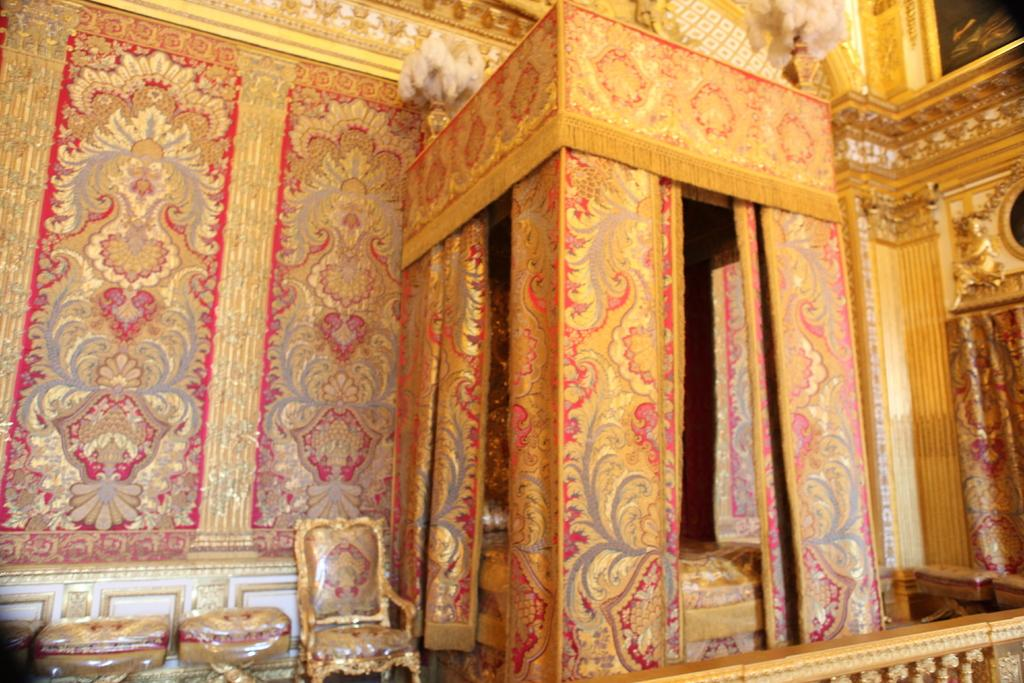What type of location is depicted in the image? The image shows an inside view of a building. What type of furniture is present in the image? There is a bed and chairs visible in the image. What type of window treatment is present in the image? There are curtains in the image. What type of structure is visible in the image? There are walls visible in the image. What other objects can be seen in the image? There are other objects present in the image. What type of sound can be heard coming from the girl in the image? There is no girl present in the image, so it is not possible to determine what sound might be heard. 